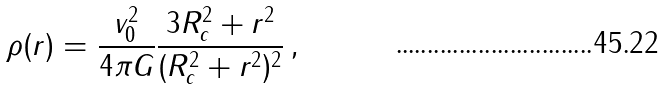Convert formula to latex. <formula><loc_0><loc_0><loc_500><loc_500>\rho ( r ) = \frac { v _ { 0 } ^ { 2 } } { 4 \pi G } \frac { 3 R _ { c } ^ { 2 } + r ^ { 2 } } { ( R _ { c } ^ { 2 } + r ^ { 2 } ) ^ { 2 } } \, ,</formula> 